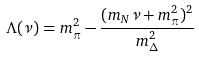<formula> <loc_0><loc_0><loc_500><loc_500>\Lambda ( \nu ) = m _ { \pi } ^ { 2 } - \frac { ( m _ { N } \nu + m _ { \pi } ^ { 2 } ) ^ { 2 } } { m _ { \Delta } ^ { 2 } }</formula> 